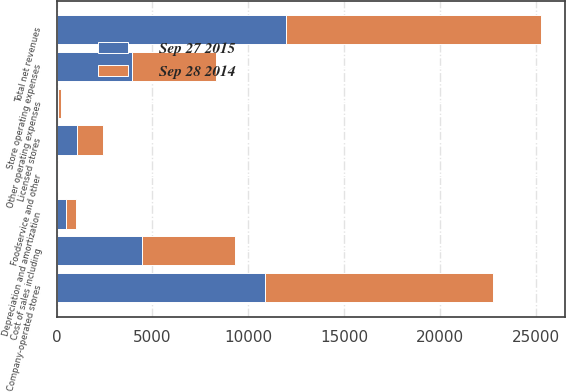Convert chart. <chart><loc_0><loc_0><loc_500><loc_500><stacked_bar_chart><ecel><fcel>Company-operated stores<fcel>Licensed stores<fcel>Foodservice and other<fcel>Total net revenues<fcel>Cost of sales including<fcel>Store operating expenses<fcel>Other operating expenses<fcel>Depreciation and amortization<nl><fcel>Sep 28 2014<fcel>11925.6<fcel>1334.4<fcel>33.4<fcel>13293.4<fcel>4845<fcel>4387.9<fcel>122.8<fcel>522.3<nl><fcel>Sep 27 2015<fcel>10866.5<fcel>1074.9<fcel>39.1<fcel>11980.5<fcel>4487<fcel>3946.8<fcel>100.4<fcel>469.5<nl></chart> 